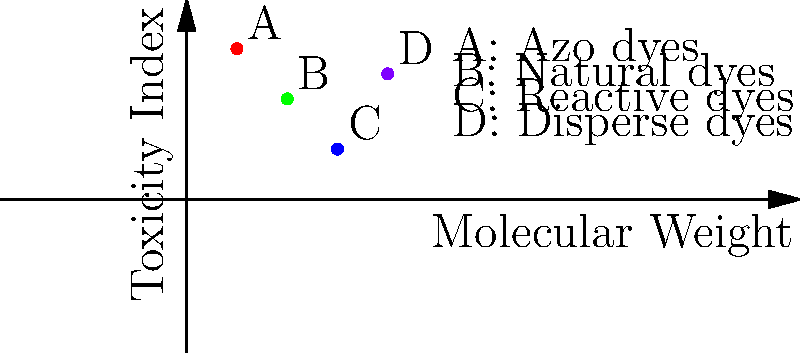Based on the topological classification of dye molecules shown in the graph, which type of dye would be most suitable for promoting in eco-friendly regulations, considering both molecular weight and toxicity index? To determine the most suitable dye for eco-friendly regulations, we need to analyze both the molecular weight and toxicity index of each dye type:

1. Identify the dye types:
   A: Azo dyes
   B: Natural dyes
   C: Reactive dyes
   D: Disperse dyes

2. Analyze the graph:
   - The x-axis represents molecular weight, increasing from left to right.
   - The y-axis represents the toxicity index, increasing from bottom to top.

3. Evaluate each dye type:
   A (Azo dyes): Low molecular weight, high toxicity
   B (Natural dyes): Low-medium molecular weight, medium toxicity
   C (Reactive dyes): Medium-high molecular weight, low toxicity
   D (Disperse dyes): High molecular weight, medium-high toxicity

4. Consider eco-friendly criteria:
   - Lower toxicity is preferred for environmental and health reasons.
   - Lower molecular weight often correlates with easier biodegradability.

5. Rank the dyes based on eco-friendliness:
   1. B (Natural dyes): Good balance of low-medium molecular weight and medium toxicity
   2. C (Reactive dyes): Low toxicity but higher molecular weight
   3. D (Disperse dyes): Medium-high toxicity and high molecular weight
   4. A (Azo dyes): High toxicity and low molecular weight

6. Conclusion:
   Natural dyes (B) offer the best compromise between low toxicity and low molecular weight, making them the most suitable for promoting in eco-friendly regulations.
Answer: Natural dyes 